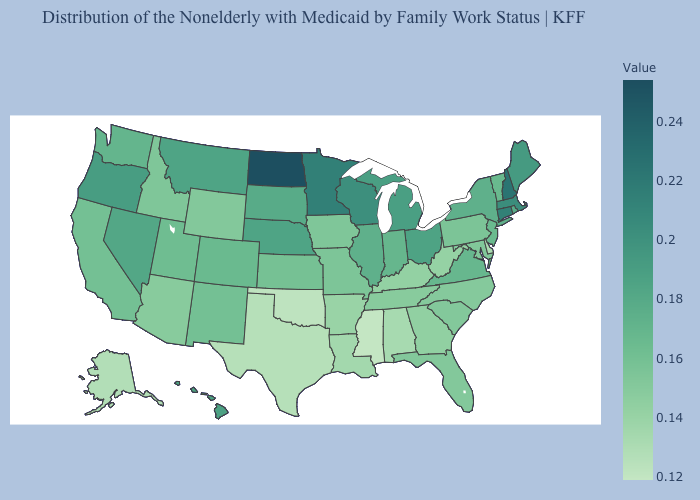Which states have the lowest value in the MidWest?
Write a very short answer. Iowa. 